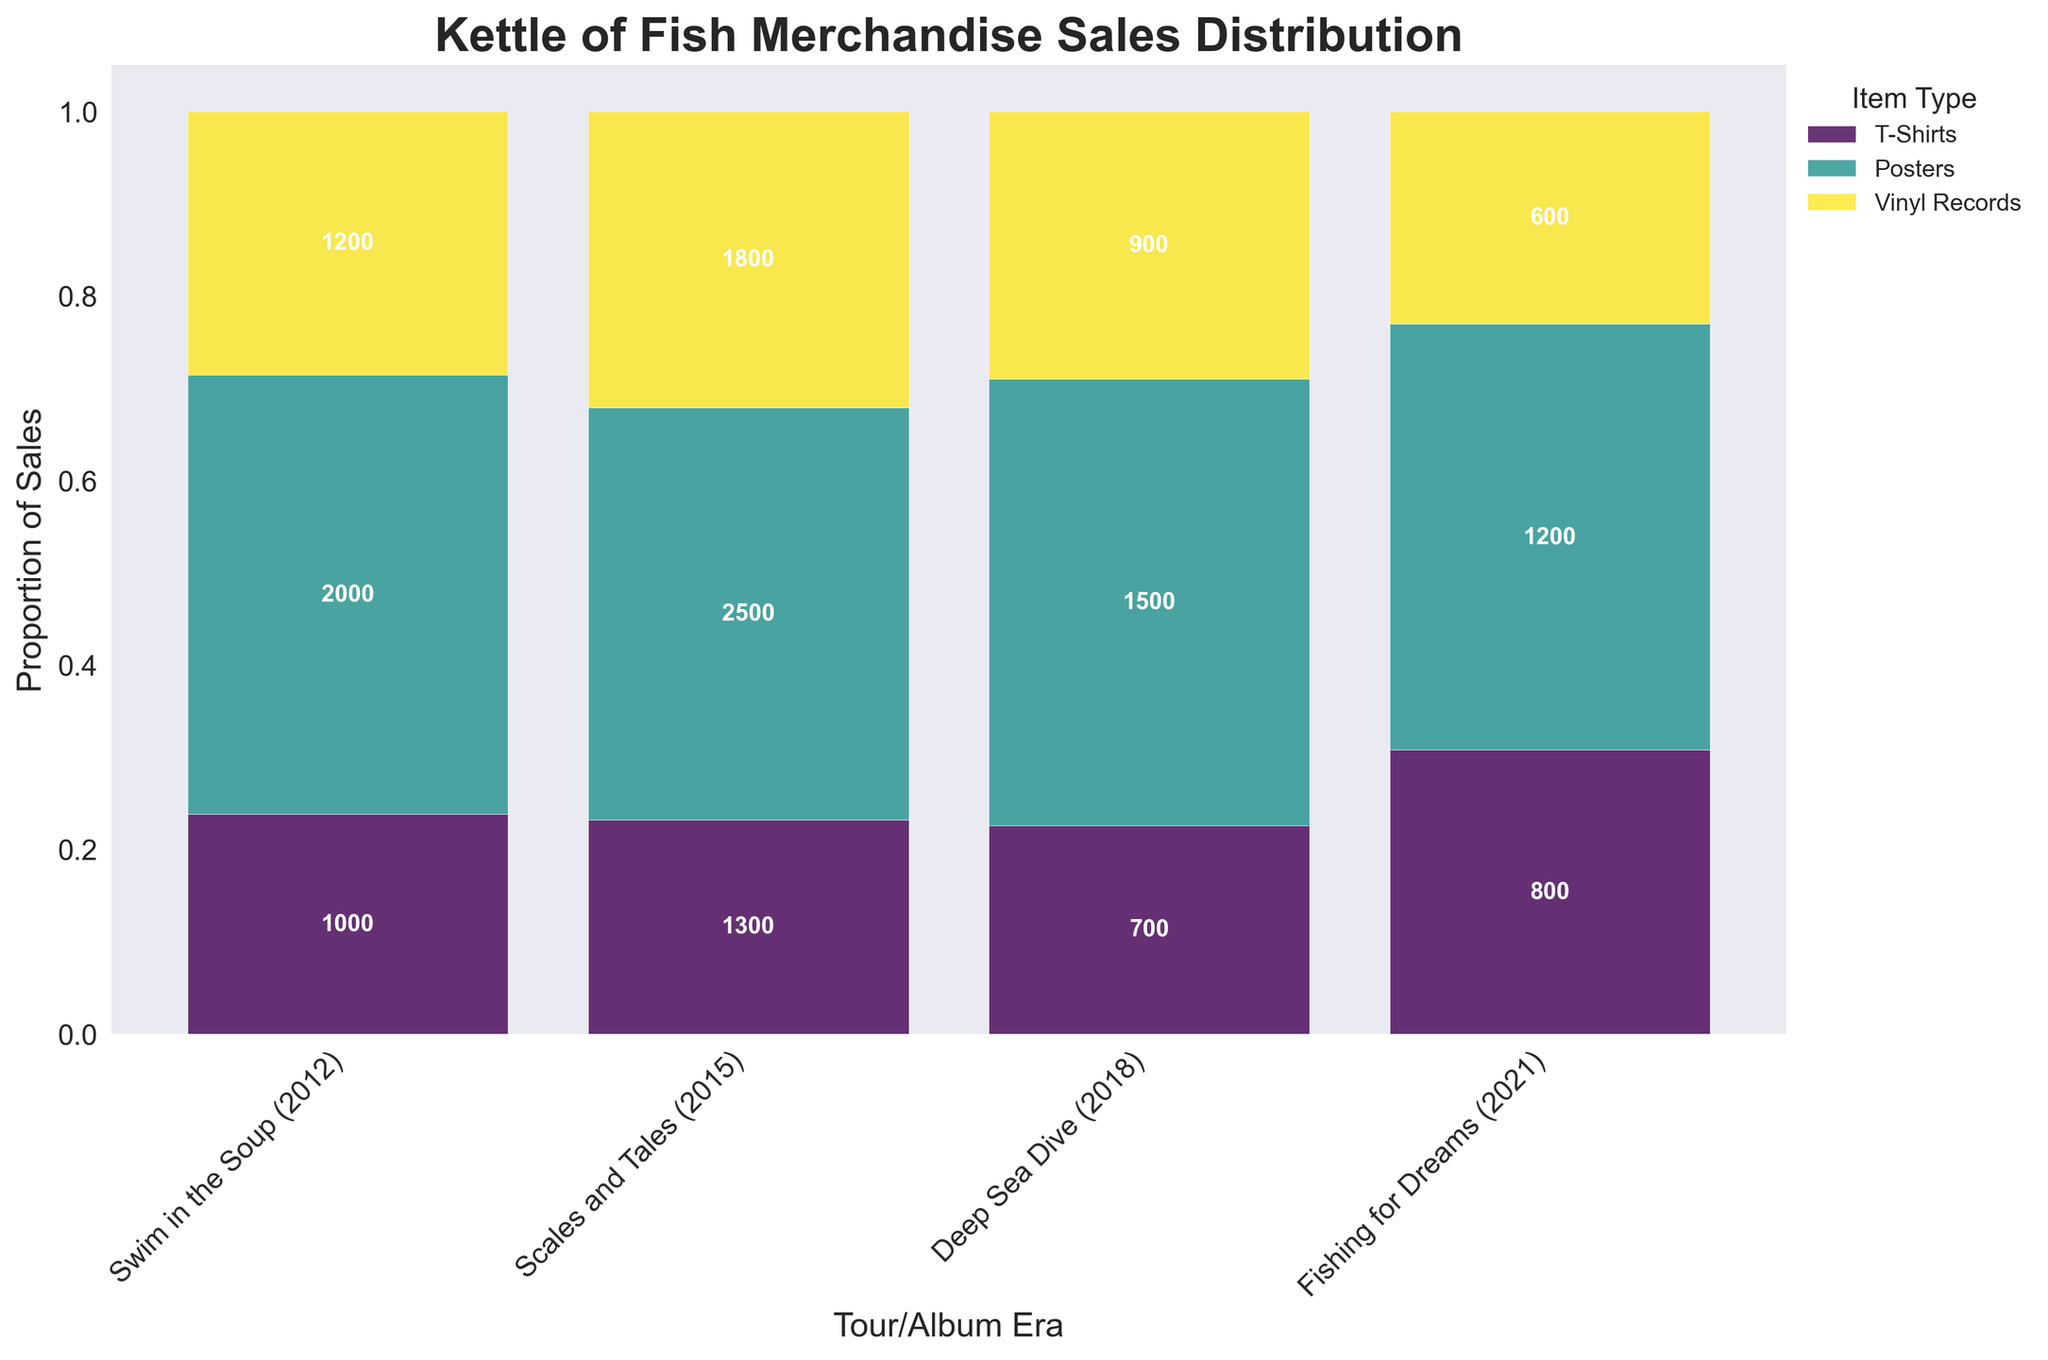Which album era had the highest total merchandise sales? The era with the highest total sales can be identified by looking at the size of the bars for each era and summing them up. "Fishing for Dreams (2021)" shows the tallest overall combined bars indicating the highest totals.
Answer: Fishing for Dreams (2021) What is the proportion of T-Shirts sales in the "Deep Sea Dive (2018)" era? On the "Deep Sea Dive (2018)" section of the plot, look at the segment corresponding to T-Shirts and note its proportion relative to the total bar height for that era.
Answer: 50% How did the sales of Vinyl Records change from the "Swim in the Soup (2012)" era to the "Scales and Tales (2015)" era? Find the size of the Vinyl Records segment for both the 2012 and 2015 eras and compare their heights. Vinyl Records sales increased from 600 to 900, showing a rise.
Answer: Increased Which item type had the most consistent sales across all eras? Check the bar segments for each item type across all four eras. Identify which item type has segments that are more evenly sized throughout the eras. T-Shirts maintain relatively high consistency.
Answer: T-Shirts How do the sales of Posters in "Scales and Tales (2015)" compare to "Fishing for Dreams (2021)"? Look at the heights of the Poster segments in both eras and compare them. Observe that the Poster segment in 2015 is smaller than in 2021.
Answer: Lower What's the percentage of total merchandise sales that Vinyl Records contributed to in the "Fishing for Dreams (2021)" era? Determine the proportion of the Vinyl Records segment in the total height for "Fishing for Dreams (2021)". Vinyl Records segment proportion is calculated as (1800 / (2500 + 1300 + 1800)) = 1800 / 5600 ≈ 32.1%.
Answer: ~32.1% Which tour/album era experienced the greatest increase in T-Shirt sales relative to the previous era? Compare the heights of T-Shirts segments across consecutive eras: from 2012 to 2015, from 2015 to 2018, and from 2018 to 2021. The largest increase occurs from 2018 to 2021.
Answer: From 2018 to 2021 